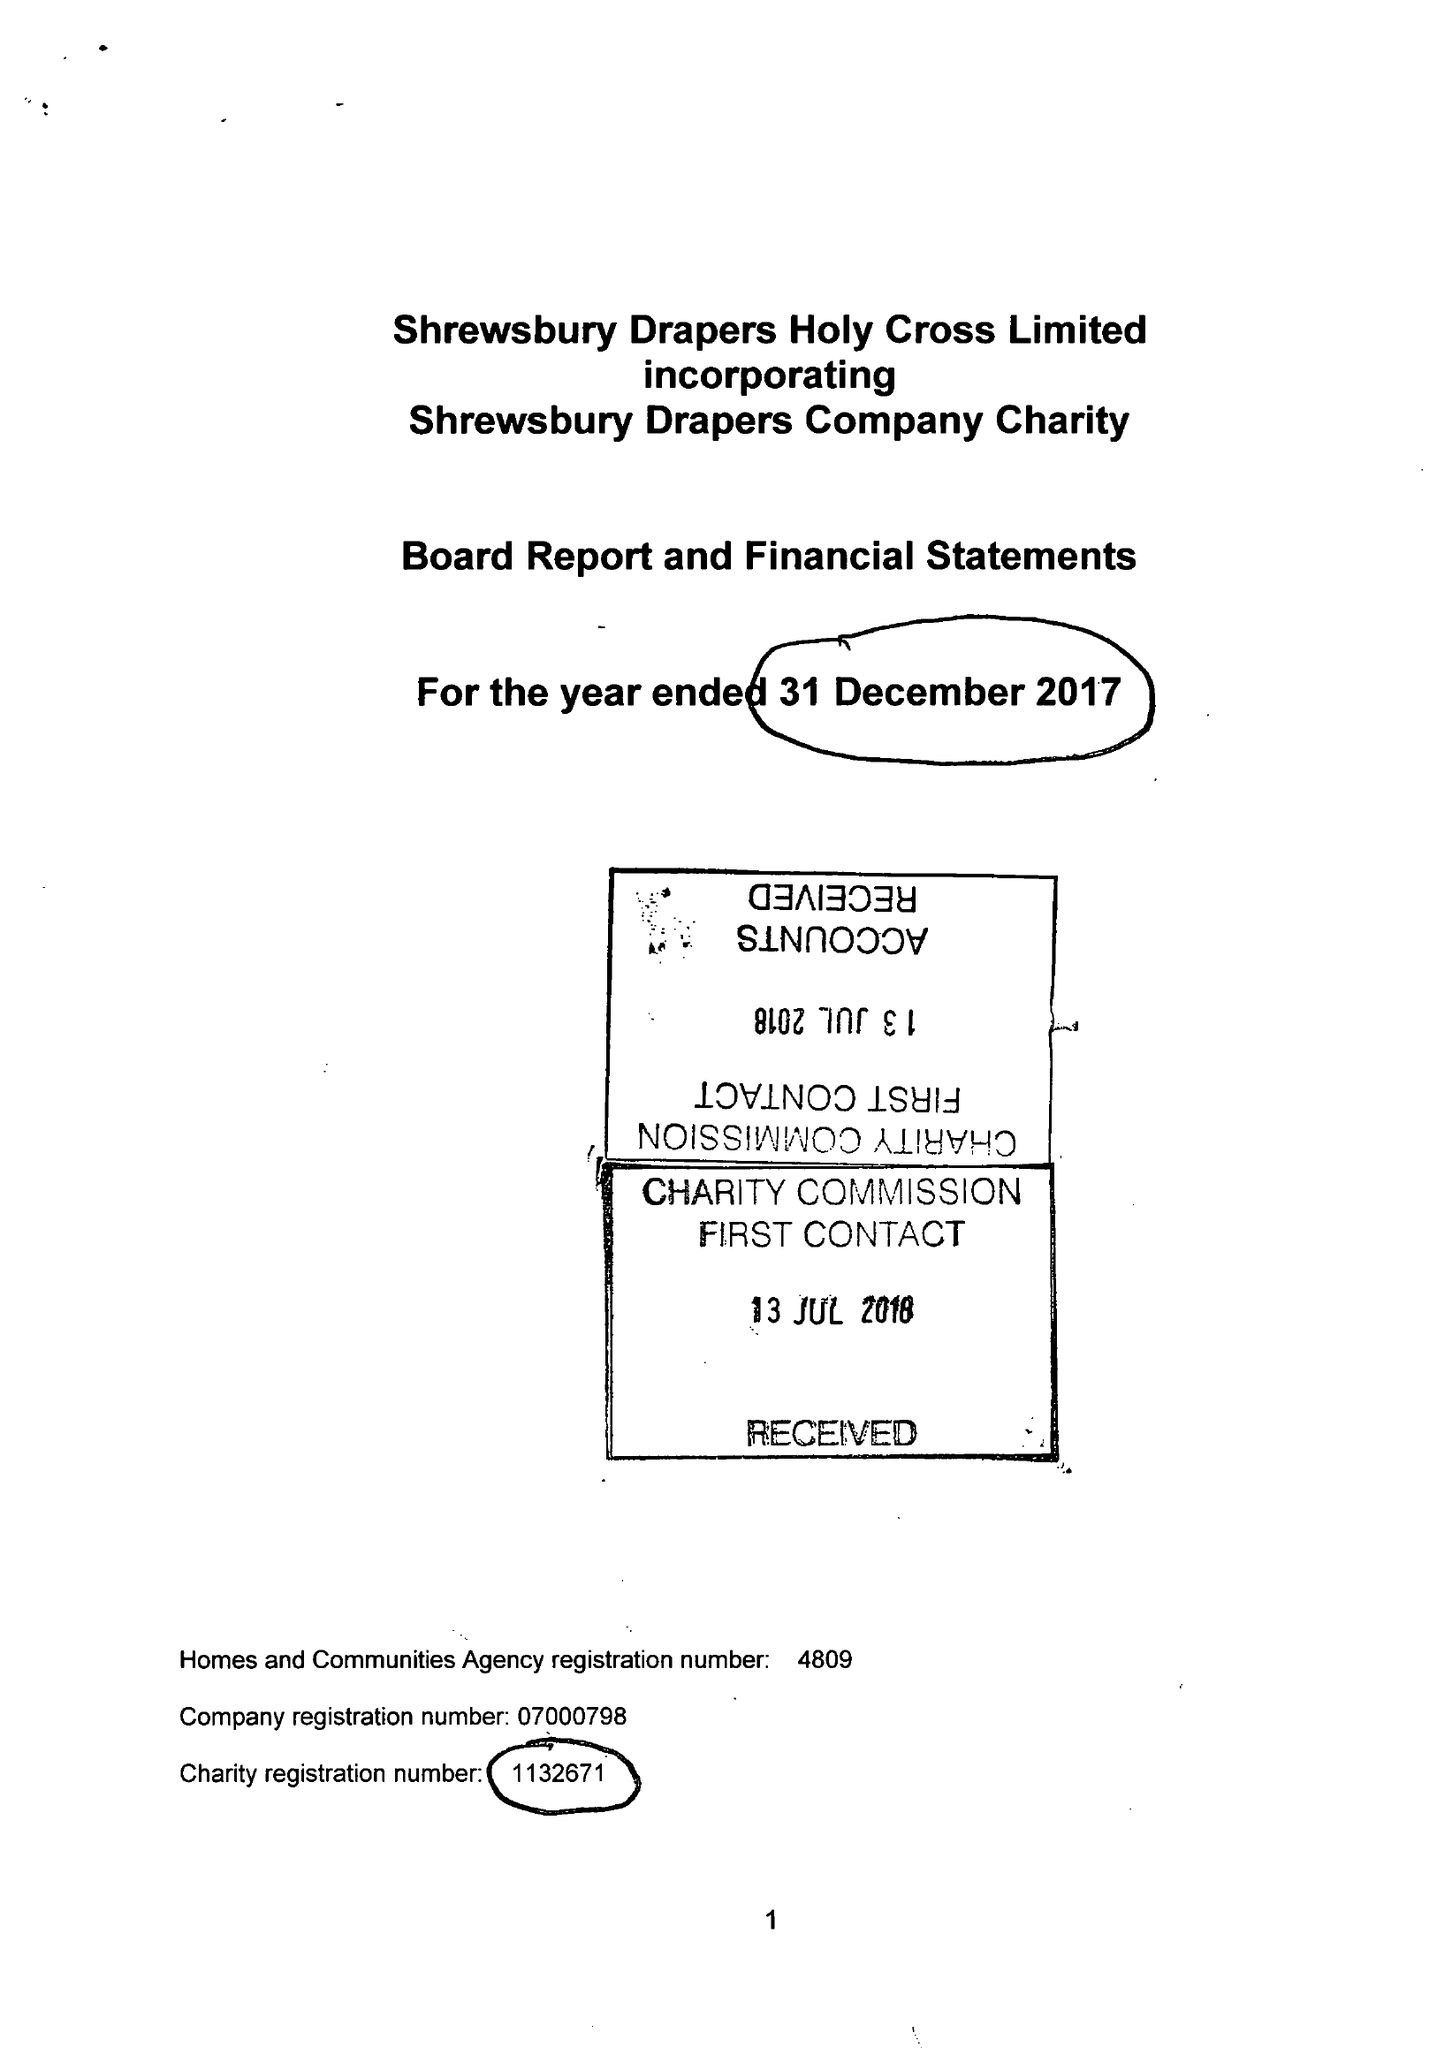What is the value for the address__post_town?
Answer the question using a single word or phrase. SHREWSBURY 